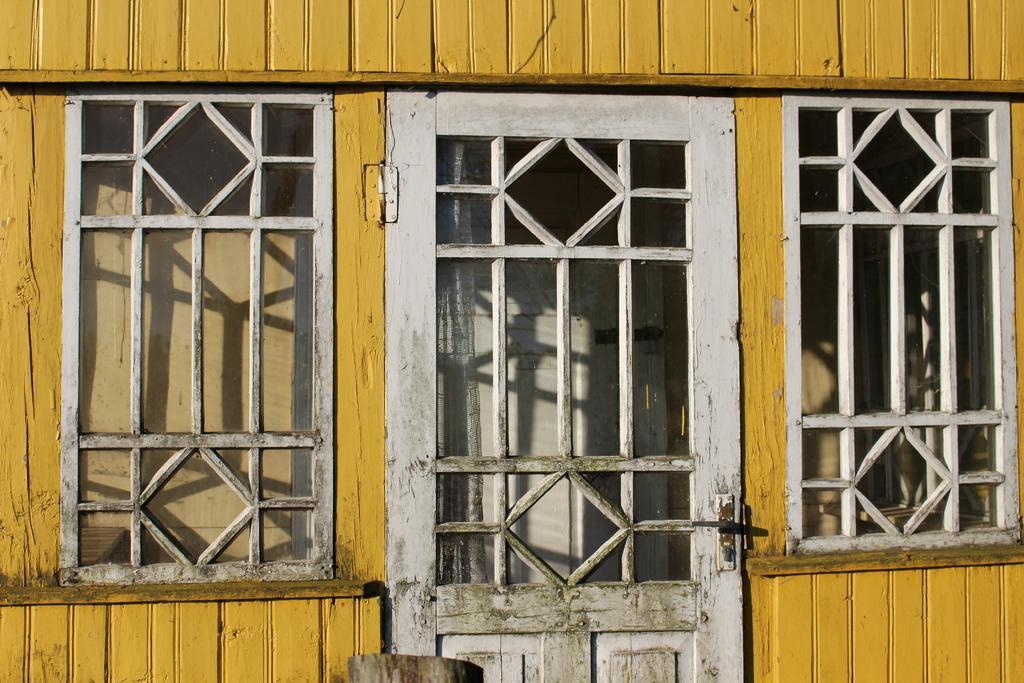Could you give a brief overview of what you see in this image? In this picture I can see a wooden door and wooden windows, this is looking like a house. 